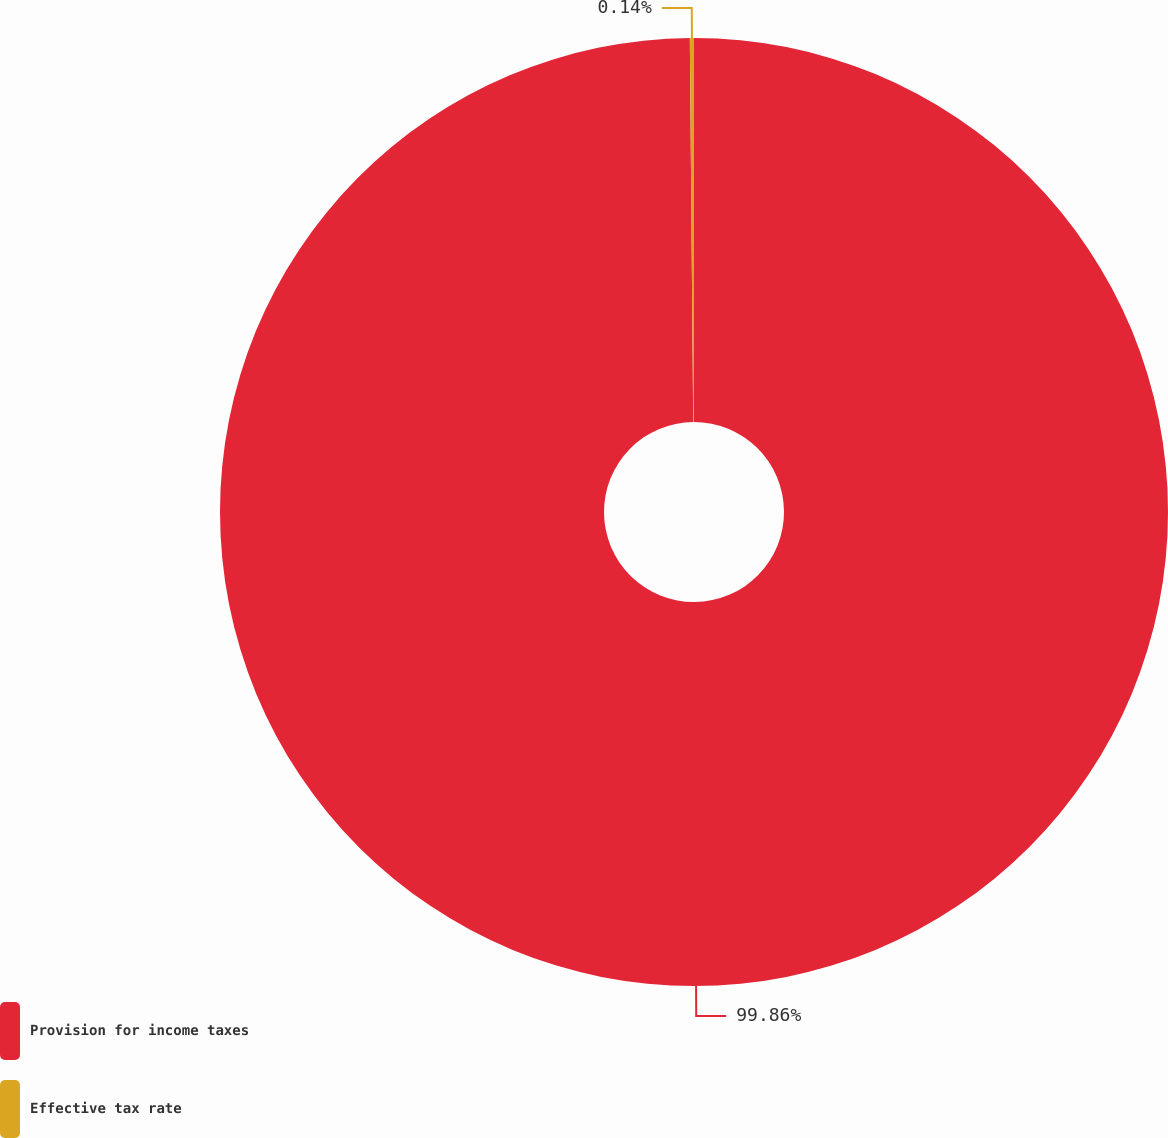Convert chart. <chart><loc_0><loc_0><loc_500><loc_500><pie_chart><fcel>Provision for income taxes<fcel>Effective tax rate<nl><fcel>99.86%<fcel>0.14%<nl></chart> 